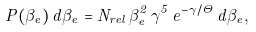Convert formula to latex. <formula><loc_0><loc_0><loc_500><loc_500>P ( \beta _ { e } ) \, d \beta _ { e } = N _ { r e l } \, \beta _ { e } ^ { 2 } \, \gamma ^ { 5 } \, e ^ { - \gamma / \Theta } \, d \beta _ { e } ,</formula> 